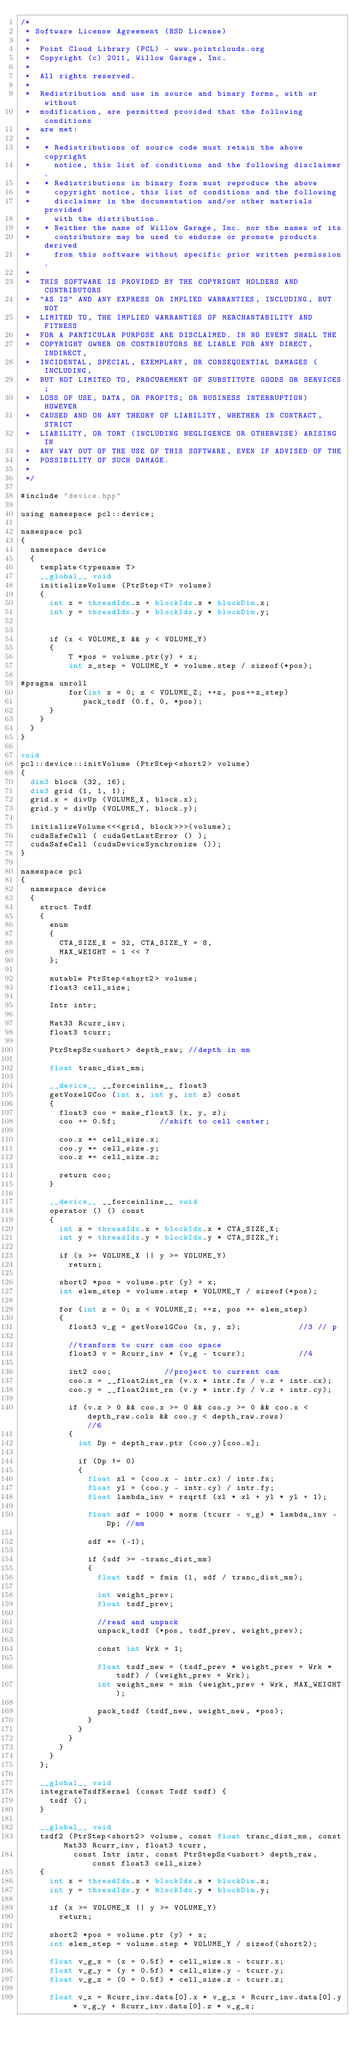<code> <loc_0><loc_0><loc_500><loc_500><_Cuda_>/*
 * Software License Agreement (BSD License)
 *
 *  Point Cloud Library (PCL) - www.pointclouds.org
 *  Copyright (c) 2011, Willow Garage, Inc.
 *
 *  All rights reserved.
 *
 *  Redistribution and use in source and binary forms, with or without
 *  modification, are permitted provided that the following conditions
 *  are met:
 *
 *   * Redistributions of source code must retain the above copyright
 *     notice, this list of conditions and the following disclaimer.
 *   * Redistributions in binary form must reproduce the above
 *     copyright notice, this list of conditions and the following
 *     disclaimer in the documentation and/or other materials provided
 *     with the distribution.
 *   * Neither the name of Willow Garage, Inc. nor the names of its
 *     contributors may be used to endorse or promote products derived
 *     from this software without specific prior written permission.
 *
 *  THIS SOFTWARE IS PROVIDED BY THE COPYRIGHT HOLDERS AND CONTRIBUTORS
 *  "AS IS" AND ANY EXPRESS OR IMPLIED WARRANTIES, INCLUDING, BUT NOT
 *  LIMITED TO, THE IMPLIED WARRANTIES OF MERCHANTABILITY AND FITNESS
 *  FOR A PARTICULAR PURPOSE ARE DISCLAIMED. IN NO EVENT SHALL THE
 *  COPYRIGHT OWNER OR CONTRIBUTORS BE LIABLE FOR ANY DIRECT, INDIRECT,
 *  INCIDENTAL, SPECIAL, EXEMPLARY, OR CONSEQUENTIAL DAMAGES (INCLUDING,
 *  BUT NOT LIMITED TO, PROCUREMENT OF SUBSTITUTE GOODS OR SERVICES;
 *  LOSS OF USE, DATA, OR PROFITS; OR BUSINESS INTERRUPTION) HOWEVER
 *  CAUSED AND ON ANY THEORY OF LIABILITY, WHETHER IN CONTRACT, STRICT
 *  LIABILITY, OR TORT (INCLUDING NEGLIGENCE OR OTHERWISE) ARISING IN
 *  ANY WAY OUT OF THE USE OF THIS SOFTWARE, EVEN IF ADVISED OF THE
 *  POSSIBILITY OF SUCH DAMAGE.
 *
 */

#include "device.hpp"

using namespace pcl::device;

namespace pcl
{
  namespace device
  {
    template<typename T>
    __global__ void
    initializeVolume (PtrStep<T> volume)
    {
      int x = threadIdx.x + blockIdx.x * blockDim.x;
      int y = threadIdx.y + blockIdx.y * blockDim.y;
      
      
      if (x < VOLUME_X && y < VOLUME_Y)
      {
          T *pos = volume.ptr(y) + x;
          int z_step = VOLUME_Y * volume.step / sizeof(*pos);

#pragma unroll
          for(int z = 0; z < VOLUME_Z; ++z, pos+=z_step)
             pack_tsdf (0.f, 0, *pos);
      }
    }   
  }
}

void
pcl::device::initVolume (PtrStep<short2> volume)
{
  dim3 block (32, 16);
  dim3 grid (1, 1, 1);
  grid.x = divUp (VOLUME_X, block.x);      
  grid.y = divUp (VOLUME_Y, block.y);

  initializeVolume<<<grid, block>>>(volume);
  cudaSafeCall ( cudaGetLastError () );
  cudaSafeCall (cudaDeviceSynchronize ());
}

namespace pcl
{
  namespace device
  {
    struct Tsdf
    {
      enum
      {
        CTA_SIZE_X = 32, CTA_SIZE_Y = 8,
        MAX_WEIGHT = 1 << 7
      };

      mutable PtrStep<short2> volume;
      float3 cell_size;

      Intr intr;

      Mat33 Rcurr_inv;
      float3 tcurr;

      PtrStepSz<ushort> depth_raw; //depth in mm

      float tranc_dist_mm;

      __device__ __forceinline__ float3
      getVoxelGCoo (int x, int y, int z) const
      {
        float3 coo = make_float3 (x, y, z);
        coo += 0.5f;         //shift to cell center;

        coo.x *= cell_size.x;
        coo.y *= cell_size.y;
        coo.z *= cell_size.z;

        return coo;
      }

      __device__ __forceinline__ void
      operator () () const
      {
        int x = threadIdx.x + blockIdx.x * CTA_SIZE_X;
        int y = threadIdx.y + blockIdx.y * CTA_SIZE_Y;

        if (x >= VOLUME_X || y >= VOLUME_Y)
          return;

        short2 *pos = volume.ptr (y) + x;
        int elem_step = volume.step * VOLUME_Y / sizeof(*pos);

        for (int z = 0; z < VOLUME_Z; ++z, pos += elem_step)
        {
          float3 v_g = getVoxelGCoo (x, y, z);            //3 // p

          //tranform to curr cam coo space
          float3 v = Rcurr_inv * (v_g - tcurr);           //4

          int2 coo;           //project to current cam
          coo.x = __float2int_rn (v.x * intr.fx / v.z + intr.cx);
          coo.y = __float2int_rn (v.y * intr.fy / v.z + intr.cy);

          if (v.z > 0 && coo.x >= 0 && coo.y >= 0 && coo.x < depth_raw.cols && coo.y < depth_raw.rows)           //6
          {
            int Dp = depth_raw.ptr (coo.y)[coo.x];

            if (Dp != 0)
            {
              float xl = (coo.x - intr.cx) / intr.fx;
              float yl = (coo.y - intr.cy) / intr.fy;
              float lambda_inv = rsqrtf (xl * xl + yl * yl + 1);

              float sdf = 1000 * norm (tcurr - v_g) * lambda_inv - Dp; //mm

              sdf *= (-1);

              if (sdf >= -tranc_dist_mm)
              {
                float tsdf = fmin (1, sdf / tranc_dist_mm);

                int weight_prev;
                float tsdf_prev;

                //read and unpack
                unpack_tsdf (*pos, tsdf_prev, weight_prev);

                const int Wrk = 1;

                float tsdf_new = (tsdf_prev * weight_prev + Wrk * tsdf) / (weight_prev + Wrk);
                int weight_new = min (weight_prev + Wrk, MAX_WEIGHT);

                pack_tsdf (tsdf_new, weight_new, *pos);
              }
            }
          }
        }
      }
    };

    __global__ void
    integrateTsdfKernel (const Tsdf tsdf) {
      tsdf ();
    }

    __global__ void
    tsdf2 (PtrStep<short2> volume, const float tranc_dist_mm, const Mat33 Rcurr_inv, float3 tcurr,
           const Intr intr, const PtrStepSz<ushort> depth_raw, const float3 cell_size)
    {
      int x = threadIdx.x + blockIdx.x * blockDim.x;
      int y = threadIdx.y + blockIdx.y * blockDim.y;

      if (x >= VOLUME_X || y >= VOLUME_Y)
        return;

      short2 *pos = volume.ptr (y) + x;
      int elem_step = volume.step * VOLUME_Y / sizeof(short2);

      float v_g_x = (x + 0.5f) * cell_size.x - tcurr.x;
      float v_g_y = (y + 0.5f) * cell_size.y - tcurr.y;
      float v_g_z = (0 + 0.5f) * cell_size.z - tcurr.z;

      float v_x = Rcurr_inv.data[0].x * v_g_x + Rcurr_inv.data[0].y * v_g_y + Rcurr_inv.data[0].z * v_g_z;</code> 